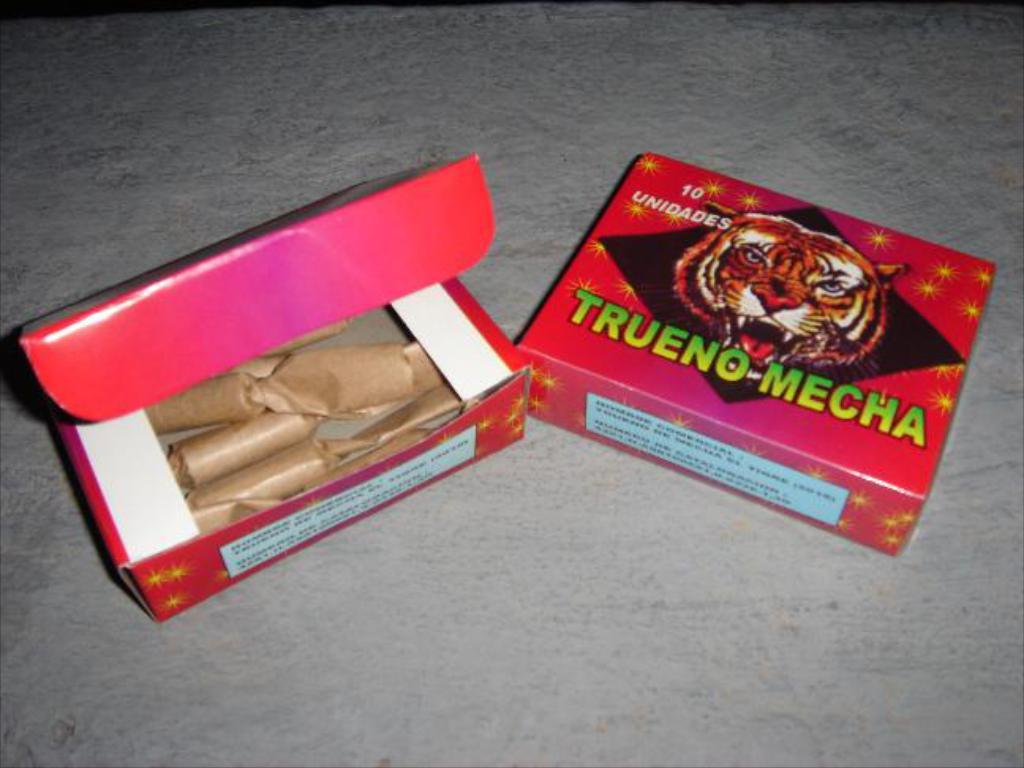<image>
Relay a brief, clear account of the picture shown. the word trueno is on a red item 